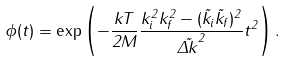<formula> <loc_0><loc_0><loc_500><loc_500>\phi ( t ) = \exp \left ( - \frac { k T } { 2 M } \frac { k _ { i } ^ { 2 } k _ { f } ^ { 2 } - ( \vec { k } _ { i } \vec { k } _ { f } ) ^ { 2 } } { \vec { \Delta k } ^ { 2 } } t ^ { 2 } \right ) .</formula> 